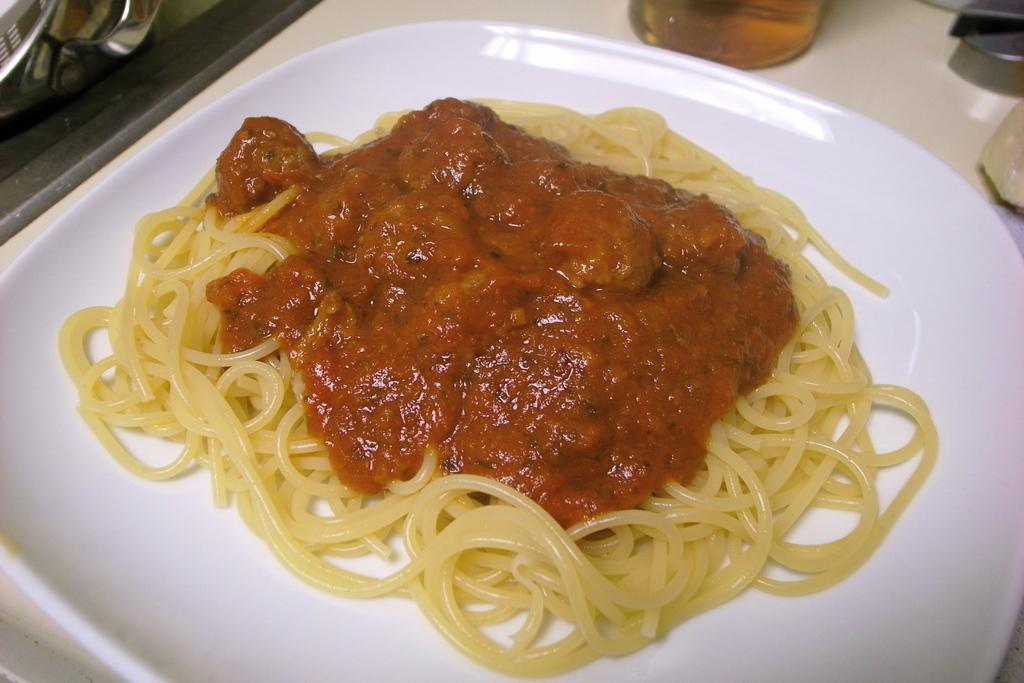What is on the plate in the image? There is food in a plate in the image. Where is the plate located? The plate is on a platform. What is in the glass in the image? There is a glass with liquid in the liquid in the image. How much of the glass is visible in the image? The glass is truncated (partially visible) in the image. What is the price of the orange in the image? There is no orange present in the image, so it is not possible to determine its price. 